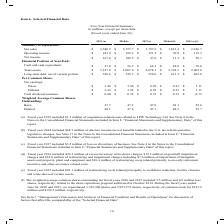According to Carpenter Technology's financial document, What did Fiscal year 2019 include? $1.2 million of acquisition-related costs related to LPW Technology Ltd. The document states: "(a) Fiscal year 2019 included $1.2 million of acquisition-related costs related to LPW Technology Ltd. See Note 4 in the Notes to the Consolidated Fin..." Also, What was the  Net sales for 2019? According to the financial document, $2,380.2 (in millions). The relevant text states: "f) 2015 (e)(f) Summary of Operations: Net sales $ 2,380.2 $ 2,157.7 $ 1,797.6 $ 1,813.4 $ 2,226.7 Operating income $ 241.4 $ 189.3 $ 121.5 $ 70.8 $ 119.3 Net..." Also, In which years was the amount of net sales provided? The document contains multiple relevant values: 2019, 2018, 2017, 2016, 2015. From the document: "2019 (a) 2018(b) 2017(c) 2016(d)(f) 2015 (e)(f) Summary of Operations: Net sales $ 2,380.2 $ 2,157.7 $ 1,797.6 $ 2019 (a) 2018(b) 2017(c) 2016(d)(f) 2..." Additionally, In which year was the Cash dividend-common the largest? According to the financial document, 2019. The relevant text states: "2019 (a) 2018(b) 2017(c) 2016(d)(f) 2015 (e)(f) Summary of Operations: Net sales $ 2,380.2 $ 2,157.7 $ 1..." Also, can you calculate: What was the change in operating income in 2019 from 2018? Based on the calculation: $241.4-$189.3, the result is 52.1 (in millions). This is based on the information: "$ 1,797.6 $ 1,813.4 $ 2,226.7 Operating income $ 241.4 $ 189.3 $ 121.5 $ 70.8 $ 119.3 Net income $ 167.0 $ 188.5 $ 47.0 $ 11.3 $ 58.7 Financial Position a .6 $ 1,813.4 $ 2,226.7 Operating income $ 241..." The key data points involved are: 189.3, 241.4. Also, can you calculate: What was the percentage change in operating income in 2019 from 2018? To answer this question, I need to perform calculations using the financial data. The calculation is: ($241.4-$189.3)/$189.3, which equals 27.52 (percentage). This is based on the information: "$ 1,797.6 $ 1,813.4 $ 2,226.7 Operating income $ 241.4 $ 189.3 $ 121.5 $ 70.8 $ 119.3 Net income $ 167.0 $ 188.5 $ 47.0 $ 11.3 $ 58.7 Financial Position a .6 $ 1,813.4 $ 2,226.7 Operating income $ 241..." The key data points involved are: 189.3, 241.4. 